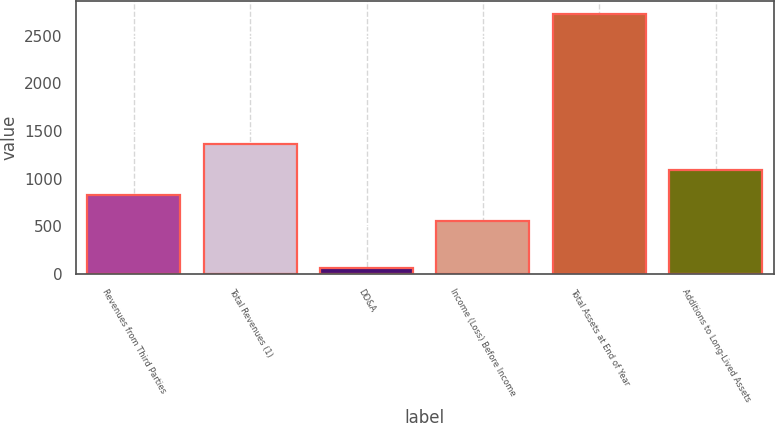Convert chart to OTSL. <chart><loc_0><loc_0><loc_500><loc_500><bar_chart><fcel>Revenues from Third Parties<fcel>Total Revenues (1)<fcel>DD&A<fcel>Income (Loss) Before Income<fcel>Total Assets at End of Year<fcel>Additions to Long-Lived Assets<nl><fcel>826.9<fcel>1358.7<fcel>69<fcel>561<fcel>2728<fcel>1092.8<nl></chart> 